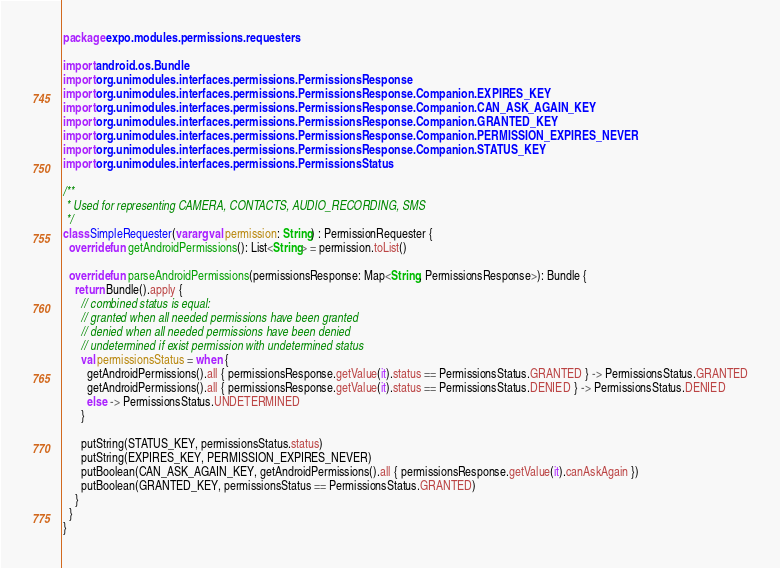Convert code to text. <code><loc_0><loc_0><loc_500><loc_500><_Kotlin_>package expo.modules.permissions.requesters

import android.os.Bundle
import org.unimodules.interfaces.permissions.PermissionsResponse
import org.unimodules.interfaces.permissions.PermissionsResponse.Companion.EXPIRES_KEY
import org.unimodules.interfaces.permissions.PermissionsResponse.Companion.CAN_ASK_AGAIN_KEY
import org.unimodules.interfaces.permissions.PermissionsResponse.Companion.GRANTED_KEY
import org.unimodules.interfaces.permissions.PermissionsResponse.Companion.PERMISSION_EXPIRES_NEVER
import org.unimodules.interfaces.permissions.PermissionsResponse.Companion.STATUS_KEY
import org.unimodules.interfaces.permissions.PermissionsStatus

/**
 * Used for representing CAMERA, CONTACTS, AUDIO_RECORDING, SMS
 */
class SimpleRequester(vararg val permission: String) : PermissionRequester {
  override fun getAndroidPermissions(): List<String> = permission.toList()

  override fun parseAndroidPermissions(permissionsResponse: Map<String, PermissionsResponse>): Bundle {
    return Bundle().apply {
      // combined status is equal:
      // granted when all needed permissions have been granted
      // denied when all needed permissions have been denied
      // undetermined if exist permission with undetermined status
      val permissionsStatus = when {
        getAndroidPermissions().all { permissionsResponse.getValue(it).status == PermissionsStatus.GRANTED } -> PermissionsStatus.GRANTED
        getAndroidPermissions().all { permissionsResponse.getValue(it).status == PermissionsStatus.DENIED } -> PermissionsStatus.DENIED
        else -> PermissionsStatus.UNDETERMINED
      }

      putString(STATUS_KEY, permissionsStatus.status)
      putString(EXPIRES_KEY, PERMISSION_EXPIRES_NEVER)
      putBoolean(CAN_ASK_AGAIN_KEY, getAndroidPermissions().all { permissionsResponse.getValue(it).canAskAgain })
      putBoolean(GRANTED_KEY, permissionsStatus == PermissionsStatus.GRANTED)
    }
  }
}
</code> 